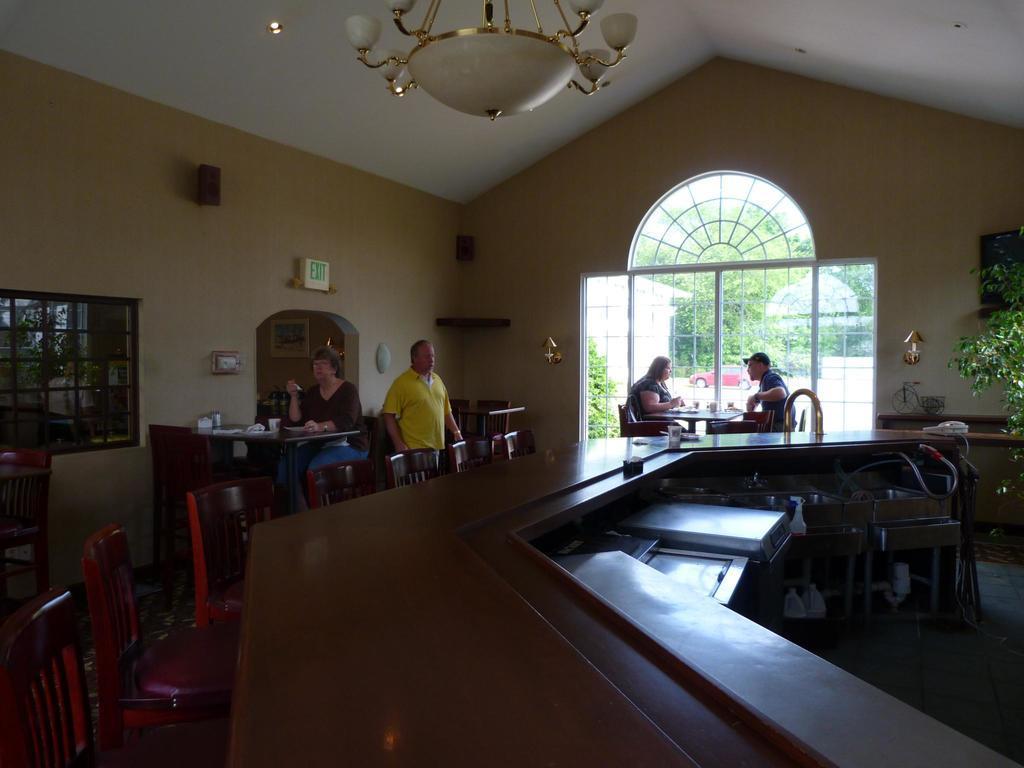Could you give a brief overview of what you see in this image? In the center of the image we can a table. On the table we can see some objects. Beside the table we can see the chairs. In the middle of the image we can see three people are sitting on the chairs and a man is standing. In the background of the image we can see the wall, boards, door, window, plant. On the right side of the image we can see some objects and floor. At the top of the image we can see the roof and chandelier. 